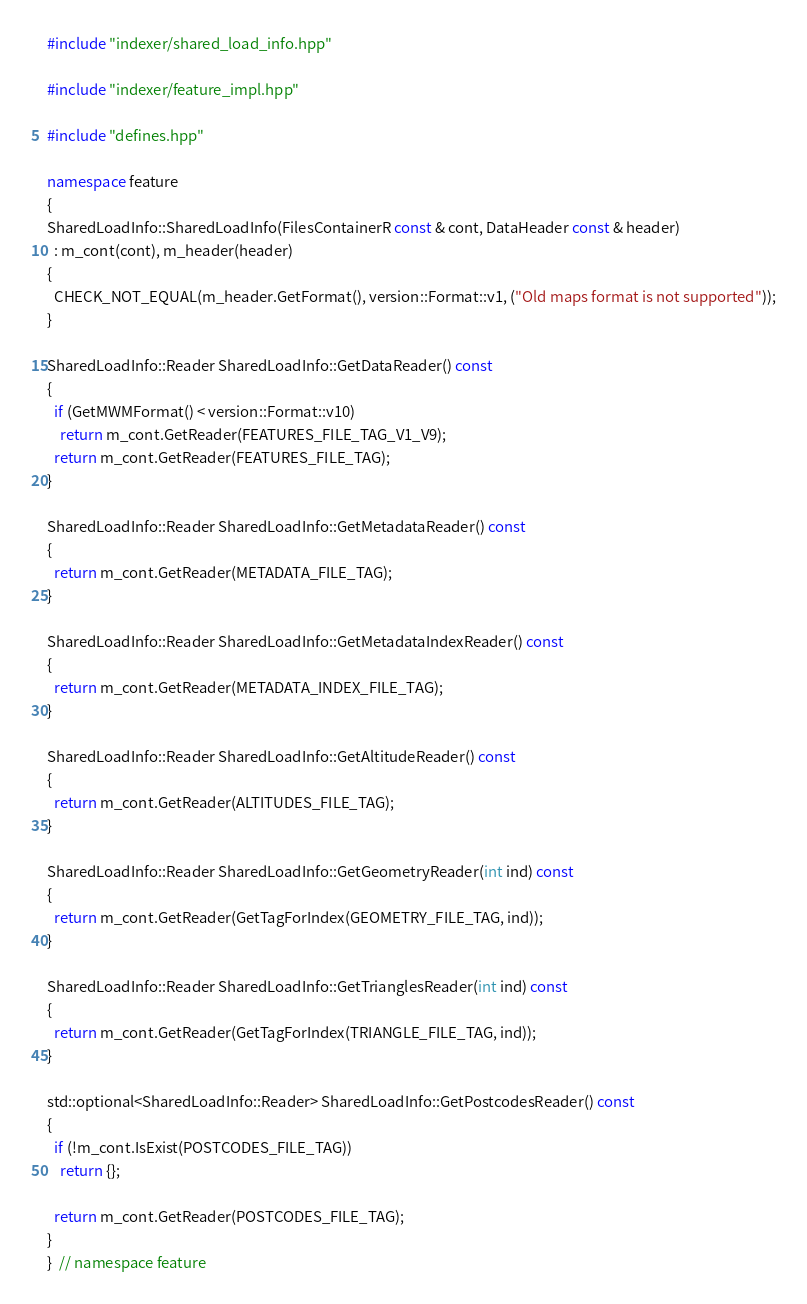Convert code to text. <code><loc_0><loc_0><loc_500><loc_500><_C++_>#include "indexer/shared_load_info.hpp"

#include "indexer/feature_impl.hpp"

#include "defines.hpp"

namespace feature
{
SharedLoadInfo::SharedLoadInfo(FilesContainerR const & cont, DataHeader const & header)
  : m_cont(cont), m_header(header)
{
  CHECK_NOT_EQUAL(m_header.GetFormat(), version::Format::v1, ("Old maps format is not supported"));
}

SharedLoadInfo::Reader SharedLoadInfo::GetDataReader() const
{
  if (GetMWMFormat() < version::Format::v10)
    return m_cont.GetReader(FEATURES_FILE_TAG_V1_V9);
  return m_cont.GetReader(FEATURES_FILE_TAG);
}

SharedLoadInfo::Reader SharedLoadInfo::GetMetadataReader() const
{
  return m_cont.GetReader(METADATA_FILE_TAG);
}

SharedLoadInfo::Reader SharedLoadInfo::GetMetadataIndexReader() const
{
  return m_cont.GetReader(METADATA_INDEX_FILE_TAG);
}

SharedLoadInfo::Reader SharedLoadInfo::GetAltitudeReader() const
{
  return m_cont.GetReader(ALTITUDES_FILE_TAG);
}

SharedLoadInfo::Reader SharedLoadInfo::GetGeometryReader(int ind) const
{
  return m_cont.GetReader(GetTagForIndex(GEOMETRY_FILE_TAG, ind));
}

SharedLoadInfo::Reader SharedLoadInfo::GetTrianglesReader(int ind) const
{
  return m_cont.GetReader(GetTagForIndex(TRIANGLE_FILE_TAG, ind));
}

std::optional<SharedLoadInfo::Reader> SharedLoadInfo::GetPostcodesReader() const
{
  if (!m_cont.IsExist(POSTCODES_FILE_TAG))
    return {};

  return m_cont.GetReader(POSTCODES_FILE_TAG);
}
}  // namespace feature
</code> 